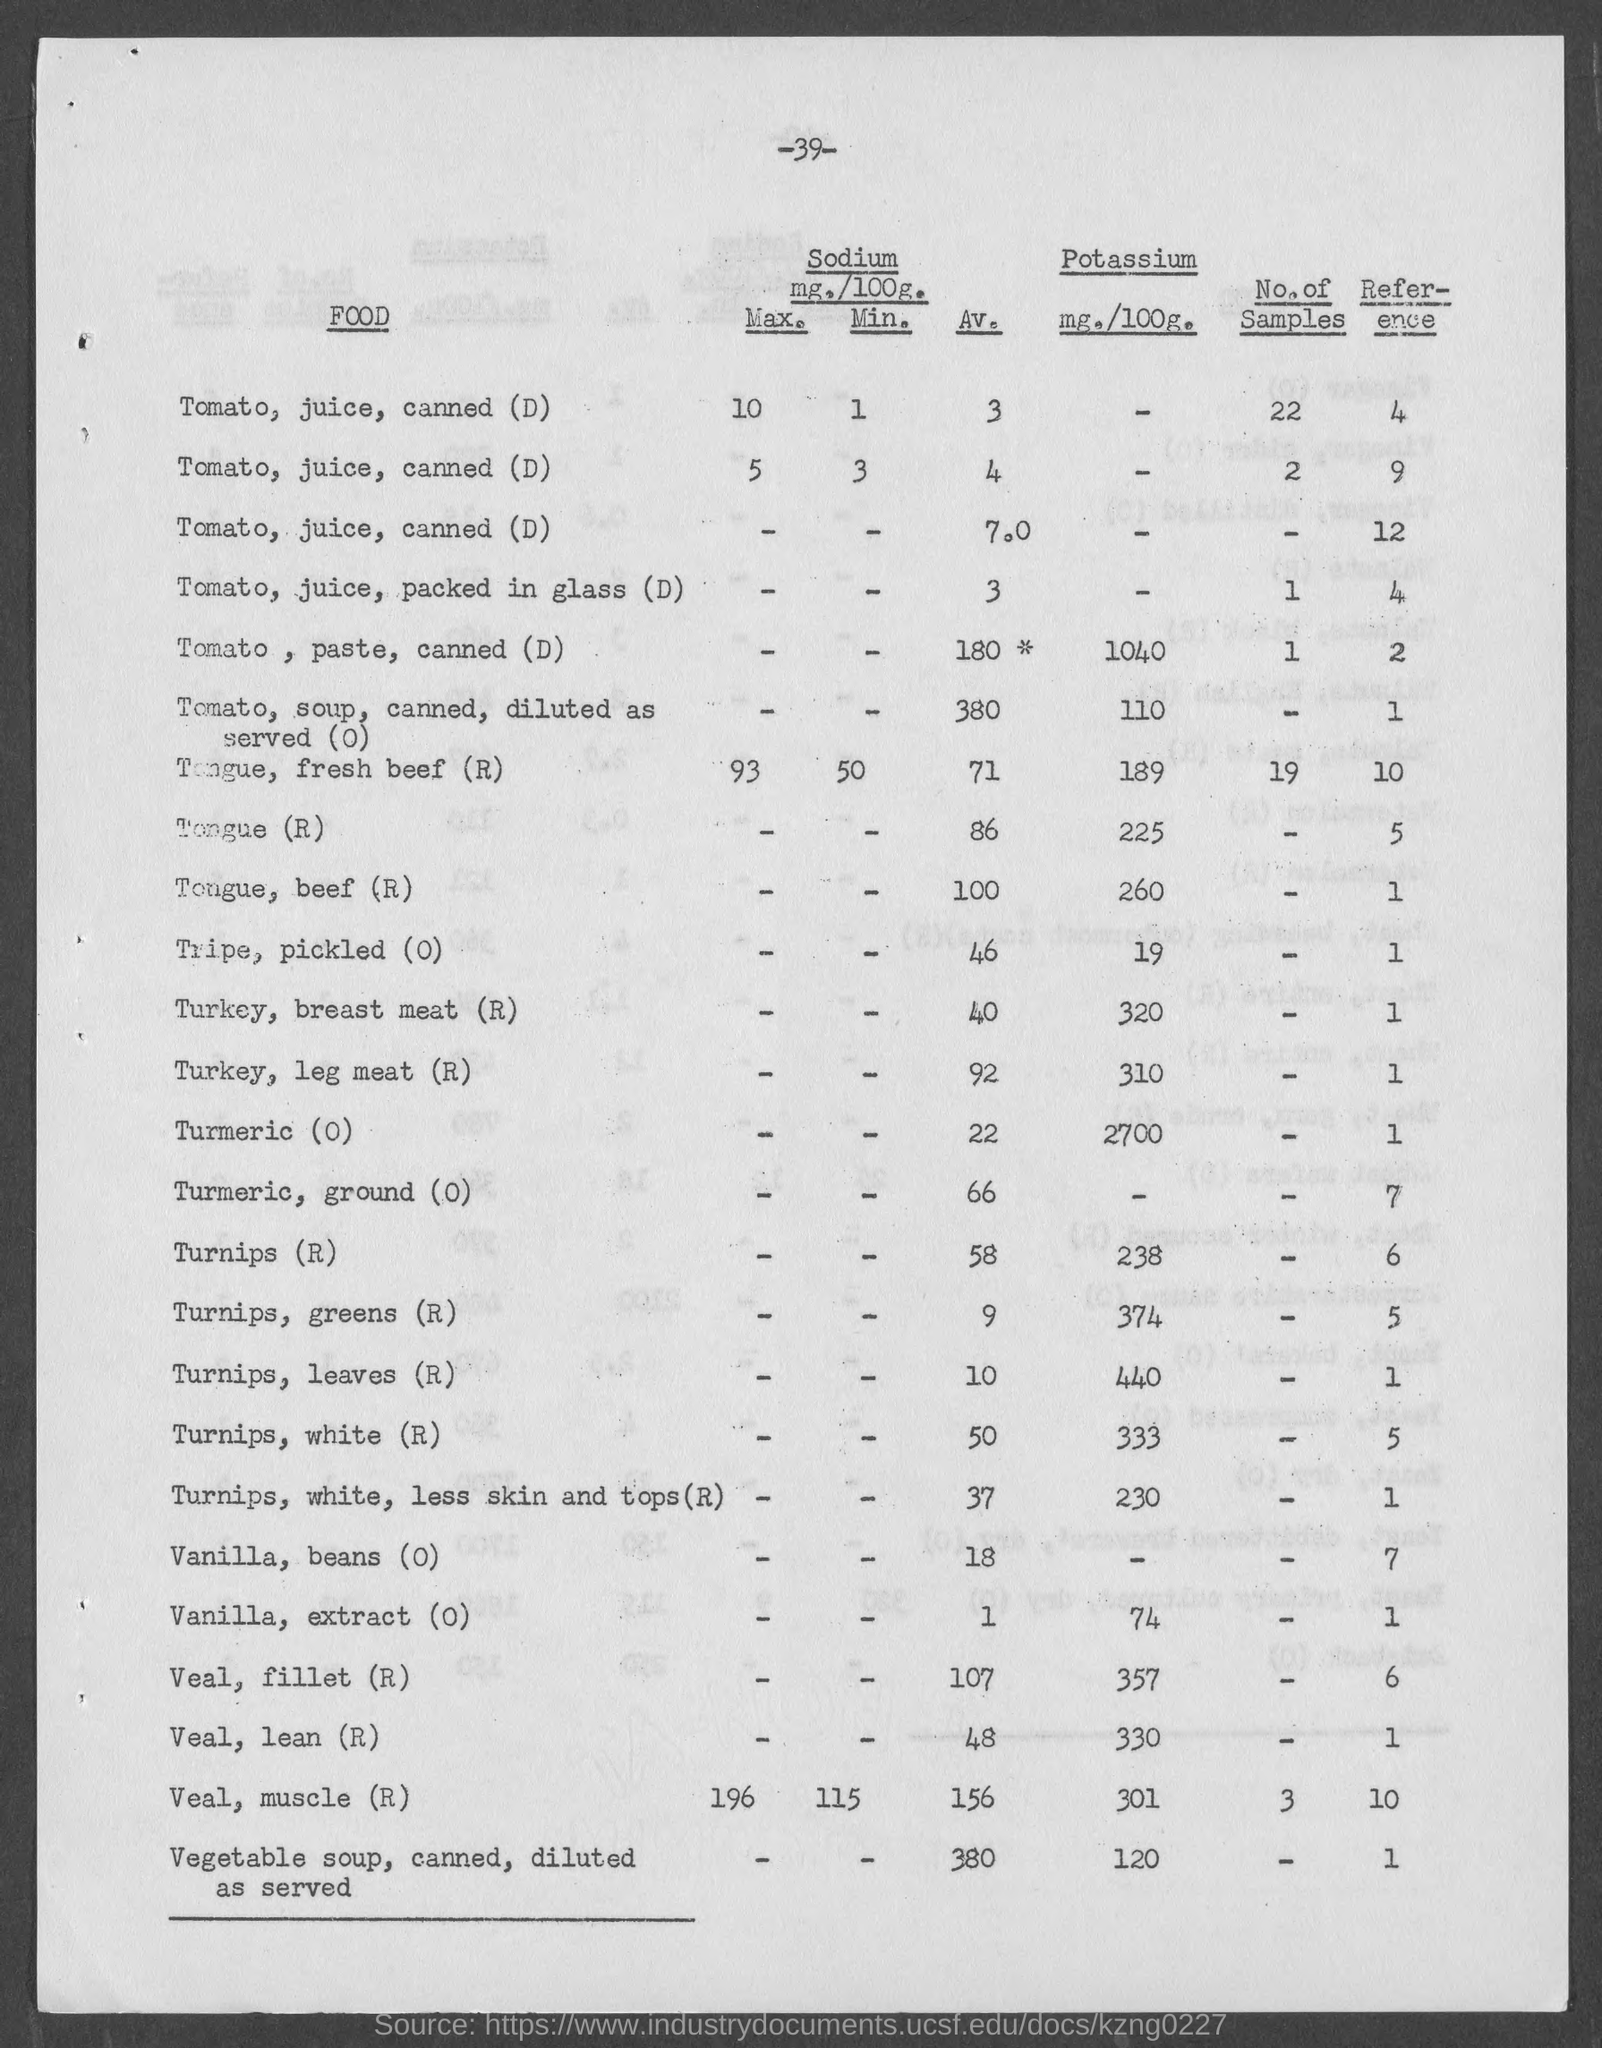Draw attention to some important aspects in this diagram. The average value of vanilla beans, specifically vanilla beans (O), is mentioned on the given page to be 18. According to the given page, the amount of potassium present in veal, lean(R) is 330 milligrams per 100 grams. The reference value for the tongue(R) as mentioned in the given form is 5. The amount of potassium present in canned tomato paste, as mentioned in the given page, is 1040 milligrams per 100 grams. What is the reference value for tongue, beef (R) mentioned in the given page? 1. 